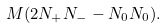Convert formula to latex. <formula><loc_0><loc_0><loc_500><loc_500>M ( 2 N _ { + } N _ { - } - N _ { 0 } N _ { 0 } ) .</formula> 